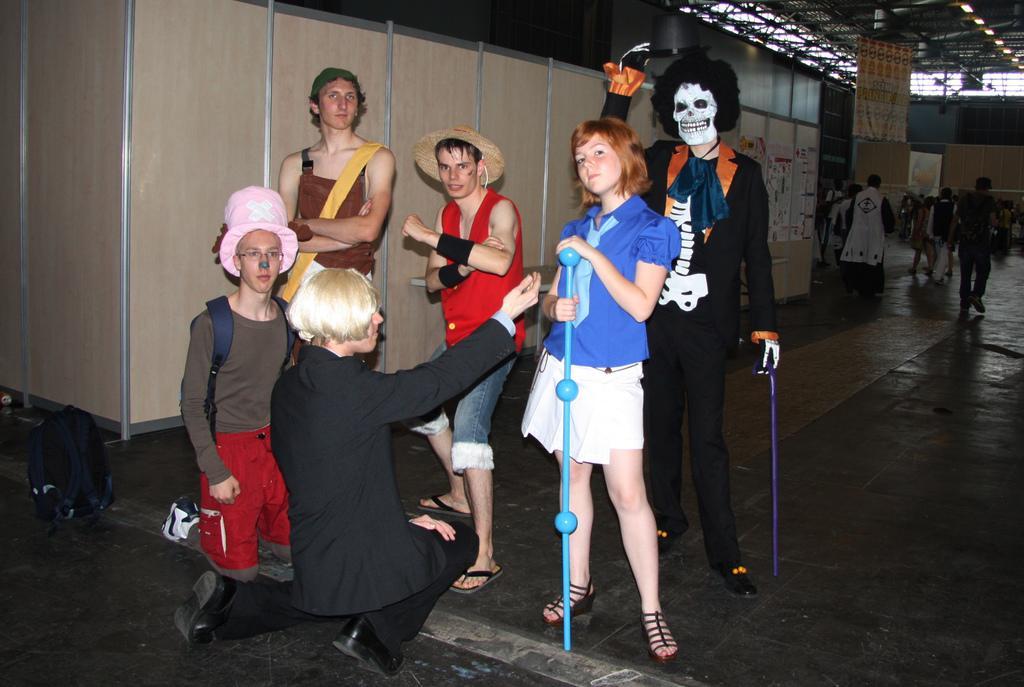How would you summarize this image in a sentence or two? In the image we can see there are people standing and two of them are sitting on the knee, they are wearing clothes, some of them are wearing shoes, hat and holding stick in their hands. Behind them there are other people walking and wearing clothes. Here we can see the bag, wooden wall, lights and the floor. 